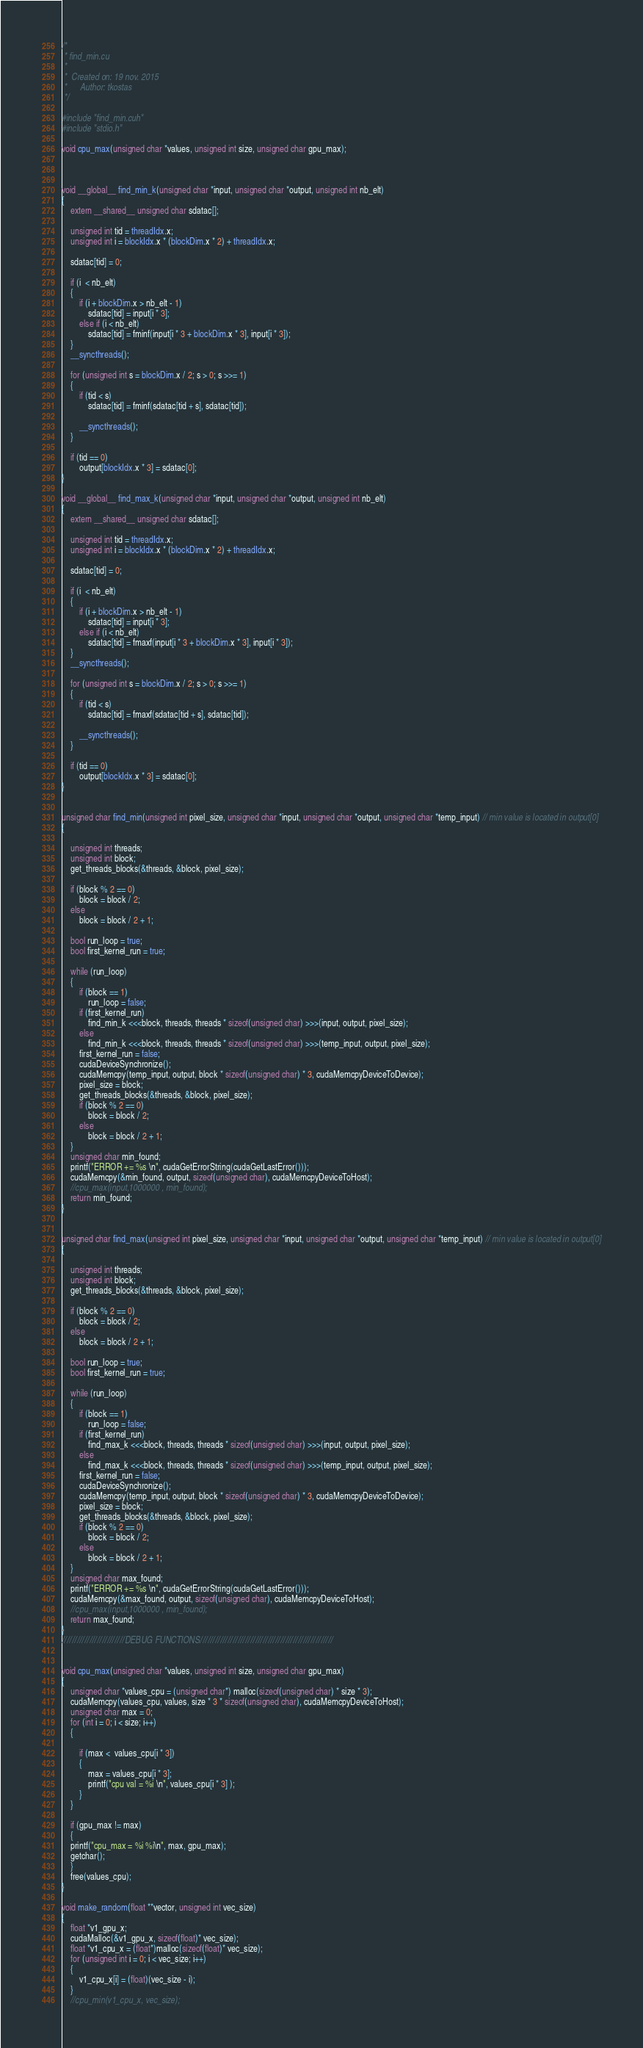Convert code to text. <code><loc_0><loc_0><loc_500><loc_500><_Cuda_>/*
 * find_min.cu
 *
 *  Created on: 19 nov. 2015
 *      Author: tkostas
 */

#include "find_min.cuh"
#include "stdio.h"

void cpu_max(unsigned char *values, unsigned int size, unsigned char gpu_max);



void __global__ find_min_k(unsigned char *input, unsigned char *output, unsigned int nb_elt)
{
	extern __shared__ unsigned char sdatac[];

	unsigned int tid = threadIdx.x;
	unsigned int i = blockIdx.x * (blockDim.x * 2) + threadIdx.x;

	sdatac[tid] = 0;

	if (i  < nb_elt)
	{
		if (i + blockDim.x > nb_elt - 1)
			sdatac[tid] = input[i * 3];
		else if (i < nb_elt)
			sdatac[tid] = fminf(input[i * 3 + blockDim.x * 3], input[i * 3]);
	}
	__syncthreads();

	for (unsigned int s = blockDim.x / 2; s > 0; s >>= 1)
	{
		if (tid < s)
			sdatac[tid] = fminf(sdatac[tid + s], sdatac[tid]);

		__syncthreads();
	}

	if (tid == 0)
		output[blockIdx.x * 3] = sdatac[0];
}

void __global__ find_max_k(unsigned char *input, unsigned char *output, unsigned int nb_elt)
{
	extern __shared__ unsigned char sdatac[];

	unsigned int tid = threadIdx.x;
	unsigned int i = blockIdx.x * (blockDim.x * 2) + threadIdx.x;

	sdatac[tid] = 0;

	if (i  < nb_elt)
	{
		if (i + blockDim.x > nb_elt - 1)
			sdatac[tid] = input[i * 3];
		else if (i < nb_elt)
			sdatac[tid] = fmaxf(input[i * 3 + blockDim.x * 3], input[i * 3]);
	}
	__syncthreads();

	for (unsigned int s = blockDim.x / 2; s > 0; s >>= 1)
	{
		if (tid < s)
			sdatac[tid] = fmaxf(sdatac[tid + s], sdatac[tid]);

		__syncthreads();
	}

	if (tid == 0)
		output[blockIdx.x * 3] = sdatac[0];
}


unsigned char find_min(unsigned int pixel_size, unsigned char *input, unsigned char *output, unsigned char *temp_input) // min value is located in output[0]
{

	unsigned int threads;
	unsigned int block;
	get_threads_blocks(&threads, &block, pixel_size);

	if (block % 2 == 0)
		block = block / 2;
	else
		block = block / 2 + 1;

	bool run_loop = true;
	bool first_kernel_run = true;

	while (run_loop)
	{
		if (block == 1)
			run_loop = false;
		if (first_kernel_run)
			find_min_k <<<block, threads, threads * sizeof(unsigned char) >>>(input, output, pixel_size);
		else
			find_min_k <<<block, threads, threads * sizeof(unsigned char) >>>(temp_input, output, pixel_size);
		first_kernel_run = false;
		cudaDeviceSynchronize();
		cudaMemcpy(temp_input, output, block * sizeof(unsigned char) * 3, cudaMemcpyDeviceToDevice);
		pixel_size = block;
		get_threads_blocks(&threads, &block, pixel_size);
		if (block % 2 == 0)
			block = block / 2;
		else
			block = block / 2 + 1;
	}
	unsigned char min_found;
	printf("ERROR += %s \n", cudaGetErrorString(cudaGetLastError()));
	cudaMemcpy(&min_found, output, sizeof(unsigned char), cudaMemcpyDeviceToHost);
	//cpu_max(input,1000000 , min_found);
	return min_found;
}


unsigned char find_max(unsigned int pixel_size, unsigned char *input, unsigned char *output, unsigned char *temp_input) // min value is located in output[0]
{

	unsigned int threads;
	unsigned int block;
	get_threads_blocks(&threads, &block, pixel_size);

	if (block % 2 == 0)
		block = block / 2;
	else
		block = block / 2 + 1;

	bool run_loop = true;
	bool first_kernel_run = true;

	while (run_loop)
	{
		if (block == 1)
			run_loop = false;
		if (first_kernel_run)
			find_max_k <<<block, threads, threads * sizeof(unsigned char) >>>(input, output, pixel_size);
		else
			find_max_k <<<block, threads, threads * sizeof(unsigned char) >>>(temp_input, output, pixel_size);
		first_kernel_run = false;
		cudaDeviceSynchronize();
		cudaMemcpy(temp_input, output, block * sizeof(unsigned char) * 3, cudaMemcpyDeviceToDevice);
		pixel_size = block;
		get_threads_blocks(&threads, &block, pixel_size);
		if (block % 2 == 0)
			block = block / 2;
		else
			block = block / 2 + 1;
	}
	unsigned char max_found;
	printf("ERROR += %s \n", cudaGetErrorString(cudaGetLastError()));
	cudaMemcpy(&max_found, output, sizeof(unsigned char), cudaMemcpyDeviceToHost);
	//cpu_max(input,1000000 , min_found);
	return max_found;
}
/////////////////////////DEBUG FUNCTIONS/////////////////////////////////////////////////////


void cpu_max(unsigned char *values, unsigned int size, unsigned char gpu_max)
{
	unsigned char *values_cpu = (unsigned char*) malloc(sizeof(unsigned char) * size * 3);
	cudaMemcpy(values_cpu, values, size * 3 * sizeof(unsigned char), cudaMemcpyDeviceToHost);
	unsigned char max = 0;
	for (int i = 0; i < size; i++)
	{

		if (max <  values_cpu[i * 3])
		{
			max = values_cpu[i * 3];
			printf("cpu val = %i \n", values_cpu[i * 3] );
		}
	}

	if (gpu_max != max)
	{
	printf("cpu_max = %i %i\n", max, gpu_max);
	getchar();
	}
	free(values_cpu);
}

void make_random(float **vector, unsigned int vec_size)
{
	float *v1_gpu_x;
	cudaMalloc(&v1_gpu_x, sizeof(float)* vec_size);
	float *v1_cpu_x = (float*)malloc(sizeof(float)* vec_size);
	for (unsigned int i = 0; i < vec_size; i++)
	{
		v1_cpu_x[i] = (float)(vec_size - i);
	}
	//cpu_min(v1_cpu_x, vec_size);</code> 